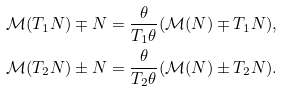<formula> <loc_0><loc_0><loc_500><loc_500>\mathcal { M } ( T _ { 1 } N ) \mp N & = \frac { \theta } { T _ { 1 } \theta } ( \mathcal { M } ( N ) \mp T _ { 1 } N ) , \\ \mathcal { M } ( T _ { 2 } N ) \pm N & = \frac { \theta } { T _ { 2 } \theta } ( \mathcal { M } ( N ) \pm T _ { 2 } N ) .</formula> 